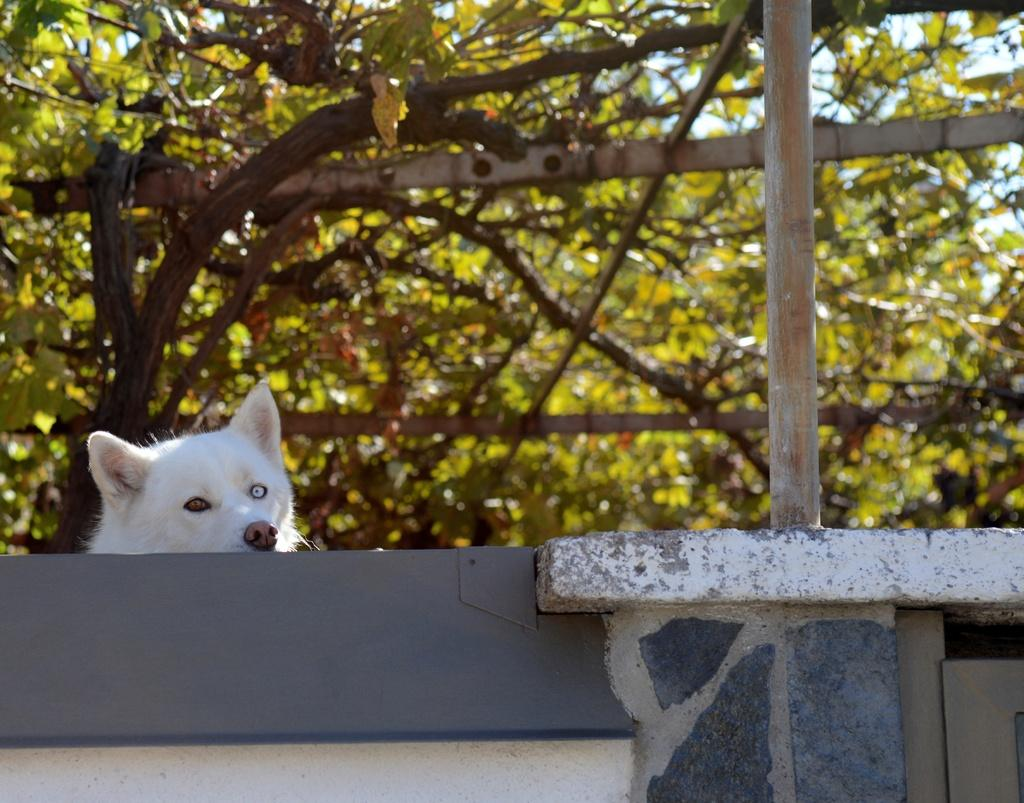What type of animal can be seen in the image? There is an animal in the image, and it is white in color. What else is present in the image besides the animal? There is a pole in the image. What can be seen in the background of the image? There are many trees and the sky visible in the background of the image. How many lines can be seen on the zebra in the image? There is no zebra present in the image, and therefore no lines can be seen on it. What type of cent is visible in the image? There is no cent present in the image. 